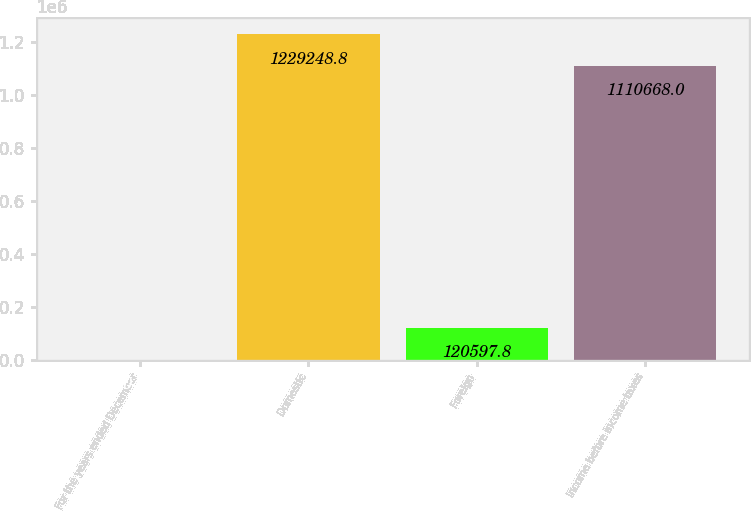Convert chart to OTSL. <chart><loc_0><loc_0><loc_500><loc_500><bar_chart><fcel>For the years ended December<fcel>Domestic<fcel>Foreign<fcel>Income before income taxes<nl><fcel>2017<fcel>1.22925e+06<fcel>120598<fcel>1.11067e+06<nl></chart> 